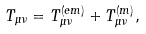Convert formula to latex. <formula><loc_0><loc_0><loc_500><loc_500>T _ { \mu \nu } = T _ { \mu \nu } ^ { ( e m ) } + T _ { \mu \nu } ^ { ( m ) } ,</formula> 